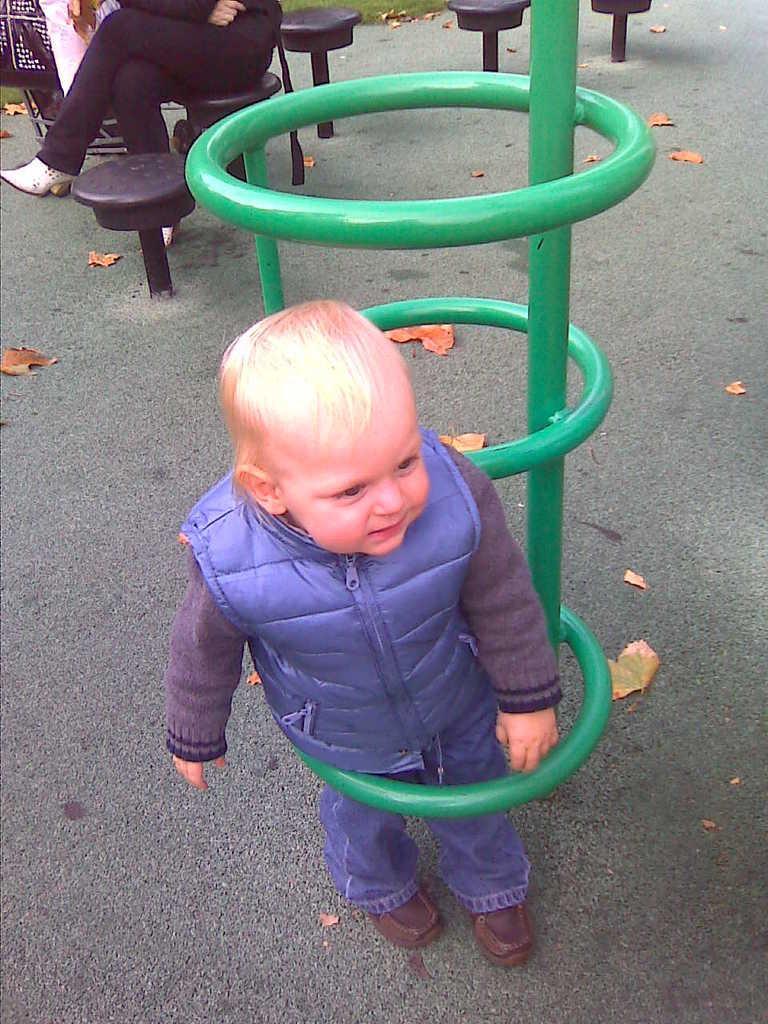Could you give a brief overview of what you see in this image? In this image we can see a boy standing in the object, which looks like a stand, there is a person truncated and sitting on the chair, there are some chairs, grass and leaves on the ground. 